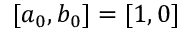Convert formula to latex. <formula><loc_0><loc_0><loc_500><loc_500>[ a _ { 0 } , b _ { 0 } ] = [ 1 , 0 ]</formula> 